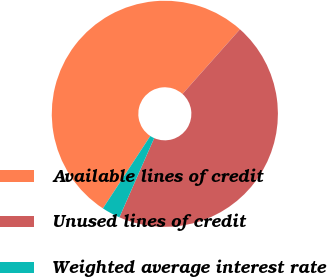Convert chart to OTSL. <chart><loc_0><loc_0><loc_500><loc_500><pie_chart><fcel>Available lines of credit<fcel>Unused lines of credit<fcel>Weighted average interest rate<nl><fcel>52.34%<fcel>45.02%<fcel>2.64%<nl></chart> 